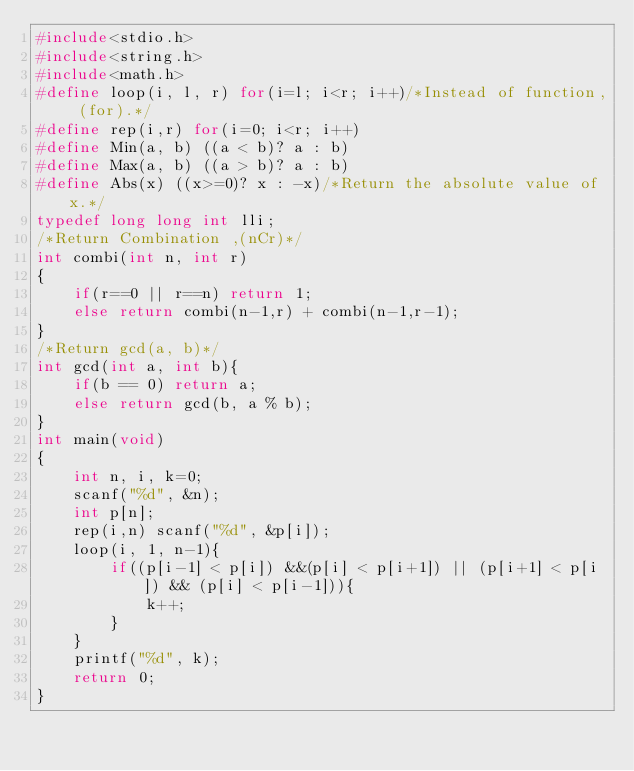<code> <loc_0><loc_0><loc_500><loc_500><_C_>#include<stdio.h>
#include<string.h>
#include<math.h>
#define loop(i, l, r) for(i=l; i<r; i++)/*Instead of function, (for).*/
#define rep(i,r) for(i=0; i<r; i++)
#define Min(a, b) ((a < b)? a : b)
#define Max(a, b) ((a > b)? a : b)
#define Abs(x) ((x>=0)? x : -x)/*Return the absolute value of x.*/
typedef long long int lli;
/*Return Combination ,(nCr)*/
int combi(int n, int r)
{
	if(r==0 || r==n) return 1;
	else return combi(n-1,r) + combi(n-1,r-1);
}
/*Return gcd(a, b)*/
int gcd(int a, int b){
	if(b == 0) return a;
	else return gcd(b, a % b);
}
int main(void)
{
	int n, i, k=0;
	scanf("%d", &n);
	int p[n];
	rep(i,n) scanf("%d", &p[i]);
	loop(i, 1, n-1){
		if((p[i-1] < p[i]) &&(p[i] < p[i+1]) || (p[i+1] < p[i]) && (p[i] < p[i-1])){
			k++;
		}
	}
	printf("%d", k);
	return 0;
}</code> 